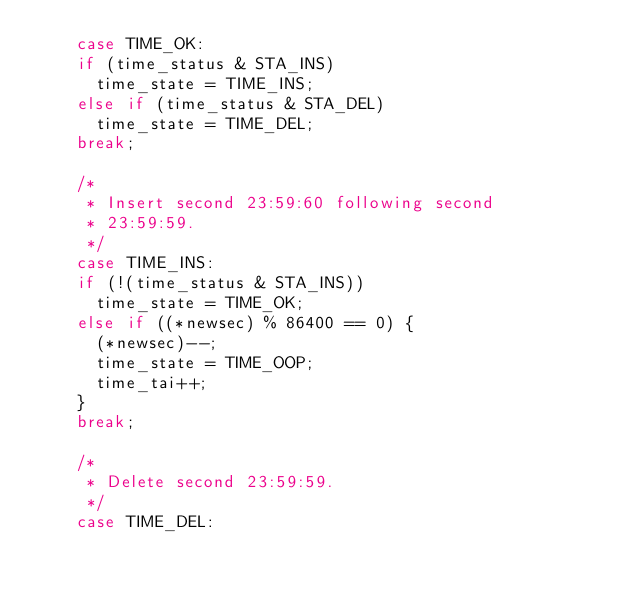<code> <loc_0><loc_0><loc_500><loc_500><_C_>		case TIME_OK:
		if (time_status & STA_INS)
			time_state = TIME_INS;
		else if (time_status & STA_DEL)
			time_state = TIME_DEL;
		break;

		/*
		 * Insert second 23:59:60 following second
		 * 23:59:59.
		 */
		case TIME_INS:
		if (!(time_status & STA_INS))
			time_state = TIME_OK;
		else if ((*newsec) % 86400 == 0) {
			(*newsec)--;
			time_state = TIME_OOP;
			time_tai++;
		}
		break;

		/*
		 * Delete second 23:59:59.
		 */
		case TIME_DEL:</code> 